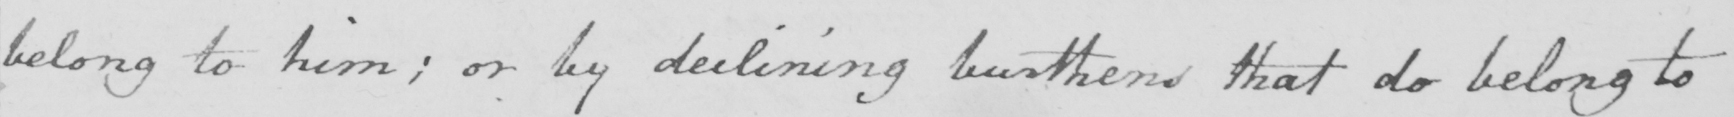What is written in this line of handwriting? belong to him; or by declining burthens that do belong to 